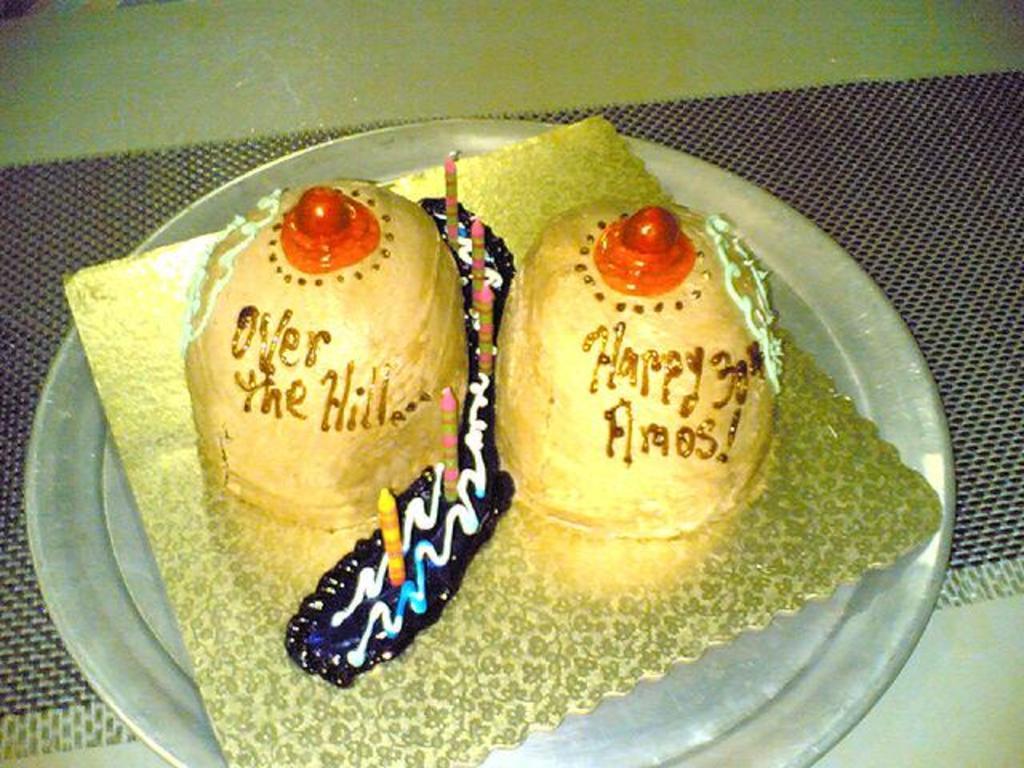Could you give a brief overview of what you see in this image? In this image we can see a serving plate which consists of cake with candles on it and placed on the table. 